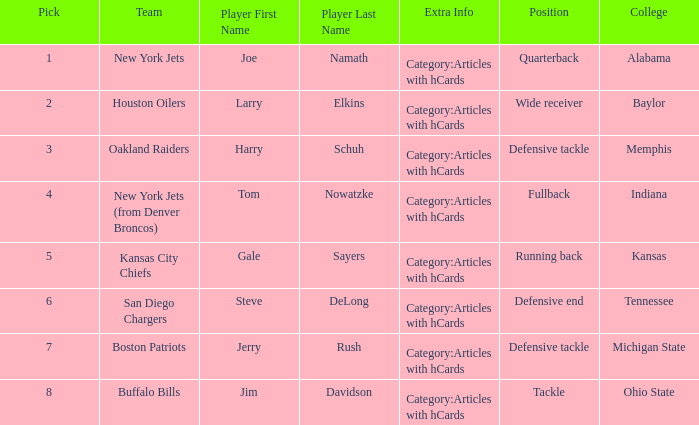Help me parse the entirety of this table. {'header': ['Pick', 'Team', 'Player First Name', 'Player Last Name', 'Extra Info', 'Position', 'College'], 'rows': [['1', 'New York Jets', 'Joe', 'Namath', 'Category:Articles with hCards', 'Quarterback', 'Alabama'], ['2', 'Houston Oilers', 'Larry', 'Elkins', 'Category:Articles with hCards', 'Wide receiver', 'Baylor'], ['3', 'Oakland Raiders', 'Harry', 'Schuh', 'Category:Articles with hCards', 'Defensive tackle', 'Memphis'], ['4', 'New York Jets (from Denver Broncos)', 'Tom', 'Nowatzke', 'Category:Articles with hCards', 'Fullback', 'Indiana'], ['5', 'Kansas City Chiefs', 'Gale', 'Sayers', 'Category:Articles with hCards', 'Running back', 'Kansas'], ['6', 'San Diego Chargers', 'Steve', 'DeLong', 'Category:Articles with hCards', 'Defensive end', 'Tennessee'], ['7', 'Boston Patriots', 'Jerry', 'Rush', 'Category:Articles with hCards', 'Defensive tackle', 'Michigan State'], ['8', 'Buffalo Bills', 'Jim', 'Davidson', 'Category:Articles with hCards', 'Tackle', 'Ohio State']]} What team has a position of running back and picked after 2? Kansas City Chiefs. 